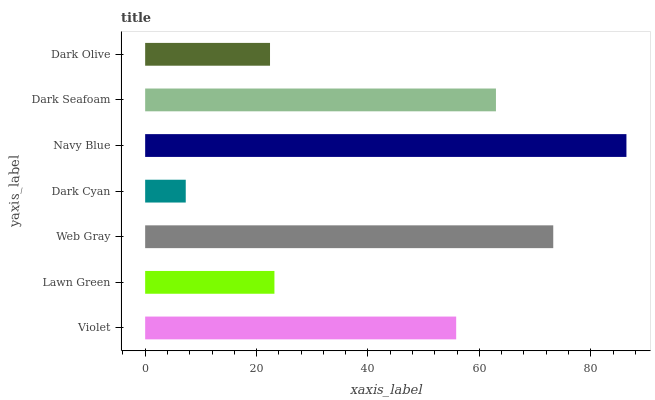Is Dark Cyan the minimum?
Answer yes or no. Yes. Is Navy Blue the maximum?
Answer yes or no. Yes. Is Lawn Green the minimum?
Answer yes or no. No. Is Lawn Green the maximum?
Answer yes or no. No. Is Violet greater than Lawn Green?
Answer yes or no. Yes. Is Lawn Green less than Violet?
Answer yes or no. Yes. Is Lawn Green greater than Violet?
Answer yes or no. No. Is Violet less than Lawn Green?
Answer yes or no. No. Is Violet the high median?
Answer yes or no. Yes. Is Violet the low median?
Answer yes or no. Yes. Is Dark Cyan the high median?
Answer yes or no. No. Is Lawn Green the low median?
Answer yes or no. No. 